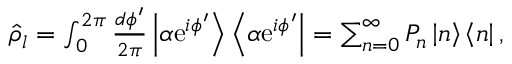Convert formula to latex. <formula><loc_0><loc_0><loc_500><loc_500>\begin{array} { r } { \hat { \rho } _ { l } = \int _ { 0 } ^ { 2 \pi } \frac { d \phi ^ { \prime } } { 2 \pi } \left | \alpha e ^ { i \phi ^ { \prime } } \right > \left < \alpha e ^ { i \phi ^ { \prime } } \right | = \sum _ { n = 0 } ^ { \infty } P _ { n } \left | n \right > \left < n \right | , } \end{array}</formula> 